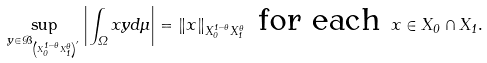<formula> <loc_0><loc_0><loc_500><loc_500>\sup _ { y \in \mathcal { B } _ { \left ( X _ { 0 } ^ { 1 - \theta } X _ { 1 } ^ { \theta } \right ) ^ { \prime } } } \left | \int _ { \Omega } x y d \mu \right | = \left \| x \right \| _ { X _ { 0 } ^ { 1 - \theta } X _ { 1 } ^ { \theta } } \text { for each } x \in X _ { 0 } \cap X _ { 1 } .</formula> 